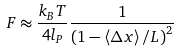<formula> <loc_0><loc_0><loc_500><loc_500>F \approx \frac { k _ { B } T } { 4 l _ { P } } \frac { 1 } { \left ( 1 - \left \langle \Delta x \right \rangle / L \right ) ^ { 2 } }</formula> 